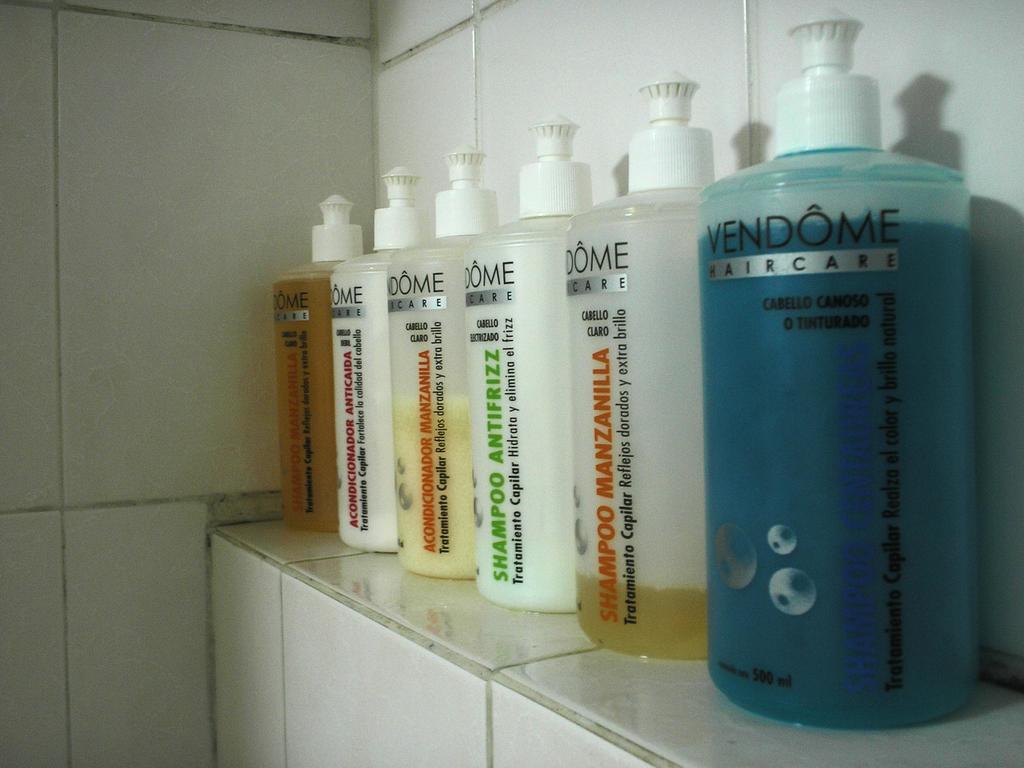Which brand are these shampoo products from?
Ensure brevity in your answer.  Vendome. What is the volume of the blue bottle?
Your answer should be compact. 500 ml. 